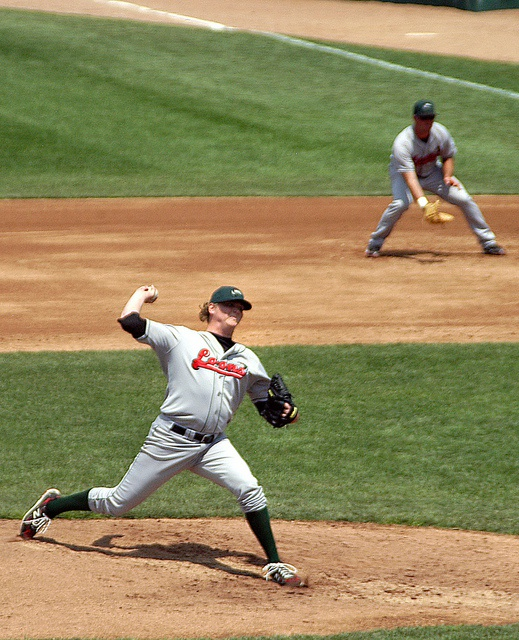Describe the objects in this image and their specific colors. I can see people in tan, white, gray, black, and darkgray tones, people in tan, gray, maroon, lightgray, and darkgray tones, baseball glove in tan, black, gray, darkgreen, and maroon tones, baseball glove in tan, brown, khaki, and salmon tones, and sports ball in tan, white, darkgray, and khaki tones in this image. 